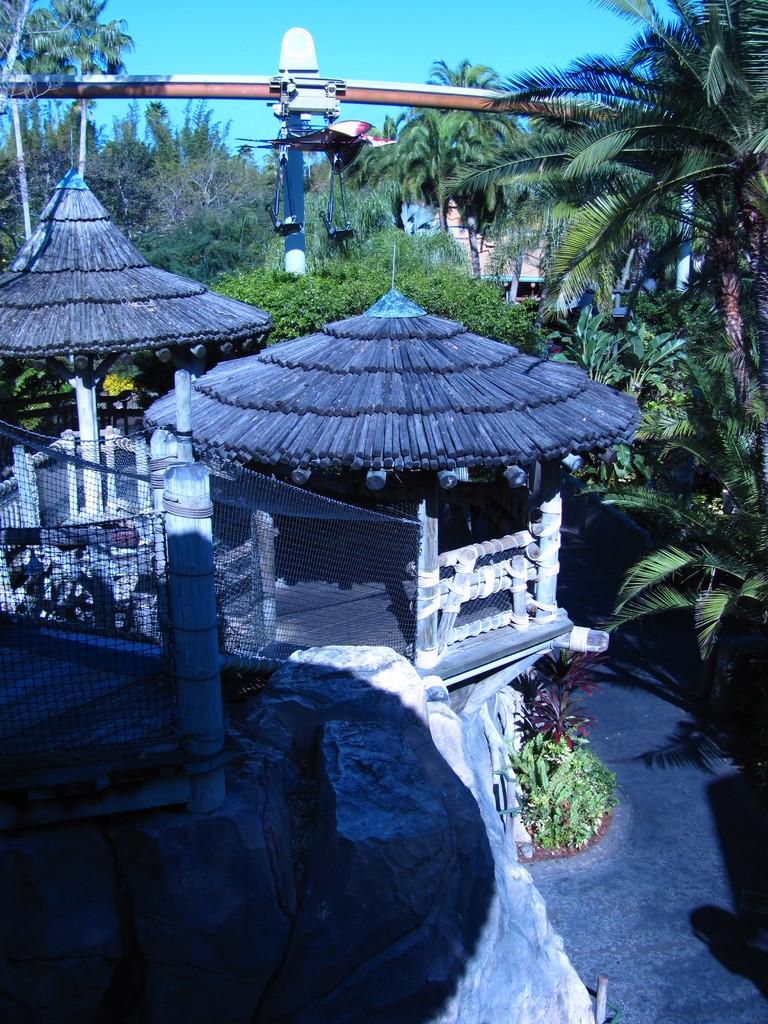What type of structures can be seen in the image? There are sheds, trees, rocks, meshes, poles, lights, buildings, and plants visible in the image. What type of terrain is visible at the bottom of the image? The ground is visible at the bottom of the image. What part of the natural environment is visible at the top of the image? The sky is visible at the top of the image. Can you identify the expert in the image who is responsible for maintaining the plants? There is no specific person or expert identified in the image; it simply shows various structures, terrain, and vegetation. 